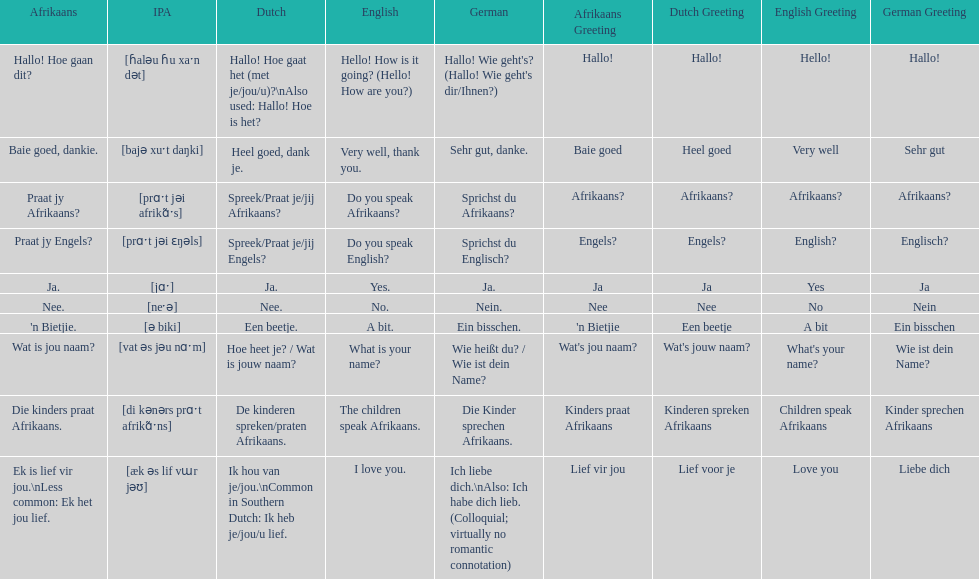Parse the table in full. {'header': ['Afrikaans', 'IPA', 'Dutch', 'English', 'German', 'Afrikaans Greeting', 'Dutch Greeting', 'English Greeting', 'German Greeting'], 'rows': [['Hallo! Hoe gaan dit?', '[ɦaləu ɦu xaˑn dət]', 'Hallo! Hoe gaat het (met je/jou/u)?\\nAlso used: Hallo! Hoe is het?', 'Hello! How is it going? (Hello! How are you?)', "Hallo! Wie geht's? (Hallo! Wie geht's dir/Ihnen?)", 'Hallo!', 'Hallo!', 'Hello!', 'Hallo!'], ['Baie goed, dankie.', '[bajə xuˑt daŋki]', 'Heel goed, dank je.', 'Very well, thank you.', 'Sehr gut, danke.', 'Baie goed', 'Heel goed', 'Very well', 'Sehr gut'], ['Praat jy Afrikaans?', '[prɑˑt jəi afrikɑ̃ˑs]', 'Spreek/Praat je/jij Afrikaans?', 'Do you speak Afrikaans?', 'Sprichst du Afrikaans?', 'Afrikaans?', 'Afrikaans?', 'Afrikaans?', 'Afrikaans?'], ['Praat jy Engels?', '[prɑˑt jəi ɛŋəls]', 'Spreek/Praat je/jij Engels?', 'Do you speak English?', 'Sprichst du Englisch?', 'Engels?', 'Engels?', 'English?', 'Englisch?'], ['Ja.', '[jɑˑ]', 'Ja.', 'Yes.', 'Ja.', 'Ja', 'Ja', 'Yes', 'Ja'], ['Nee.', '[neˑə]', 'Nee.', 'No.', 'Nein.', 'Nee', 'Nee', 'No', 'Nein'], ["'n Bietjie.", '[ə biki]', 'Een beetje.', 'A bit.', 'Ein bisschen.', "'n Bietjie", 'Een beetje', 'A bit', 'Ein bisschen'], ['Wat is jou naam?', '[vat əs jəu nɑˑm]', 'Hoe heet je? / Wat is jouw naam?', 'What is your name?', 'Wie heißt du? / Wie ist dein Name?', "Wat's jou naam?", "Wat's jouw naam?", "What's your name?", 'Wie ist dein Name?'], ['Die kinders praat Afrikaans.', '[di kənərs prɑˑt afrikɑ̃ˑns]', 'De kinderen spreken/praten Afrikaans.', 'The children speak Afrikaans.', 'Die Kinder sprechen Afrikaans.', 'Kinders praat Afrikaans', 'Kinderen spreken Afrikaans', 'Children speak Afrikaans', 'Kinder sprechen Afrikaans'], ['Ek is lief vir jou.\\nLess common: Ek het jou lief.', '[æk əs lif vɯr jəʊ]', 'Ik hou van je/jou.\\nCommon in Southern Dutch: Ik heb je/jou/u lief.', 'I love you.', 'Ich liebe dich.\\nAlso: Ich habe dich lieb. (Colloquial; virtually no romantic connotation)', 'Lief vir jou', 'Lief voor je', 'Love you', 'Liebe dich']]} Translate the following into english: 'n bietjie. A bit. 